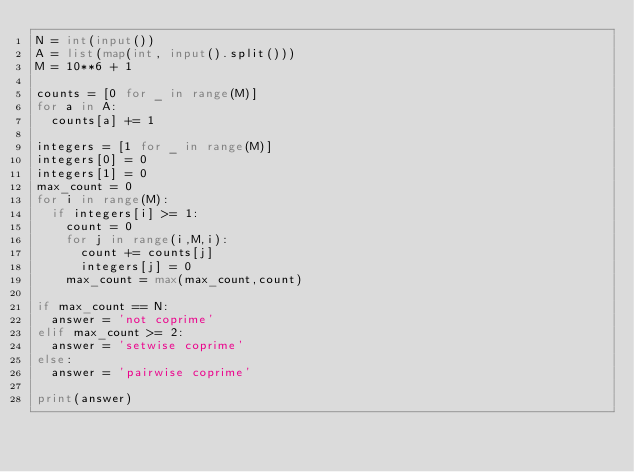<code> <loc_0><loc_0><loc_500><loc_500><_Python_>N = int(input())
A = list(map(int, input().split()))
M = 10**6 + 1

counts = [0 for _ in range(M)]
for a in A:
  counts[a] += 1

integers = [1 for _ in range(M)]
integers[0] = 0
integers[1] = 0
max_count = 0
for i in range(M):
  if integers[i] >= 1:
    count = 0
    for j in range(i,M,i):
      count += counts[j]
      integers[j] = 0
    max_count = max(max_count,count)

if max_count == N:
  answer = 'not coprime'
elif max_count >= 2:
  answer = 'setwise coprime'
else:
  answer = 'pairwise coprime'

print(answer)</code> 